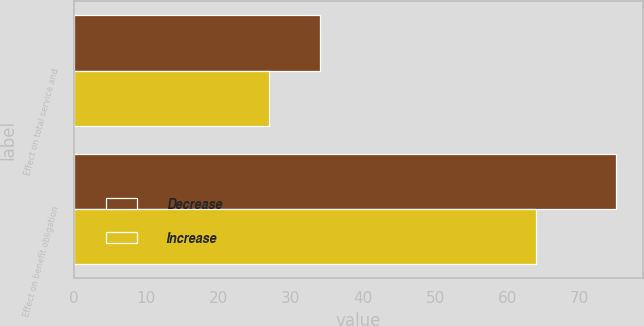Convert chart to OTSL. <chart><loc_0><loc_0><loc_500><loc_500><stacked_bar_chart><ecel><fcel>Effect on total service and<fcel>Effect on benefit obligation<nl><fcel>Decrease<fcel>34<fcel>75<nl><fcel>Increase<fcel>27<fcel>64<nl></chart> 